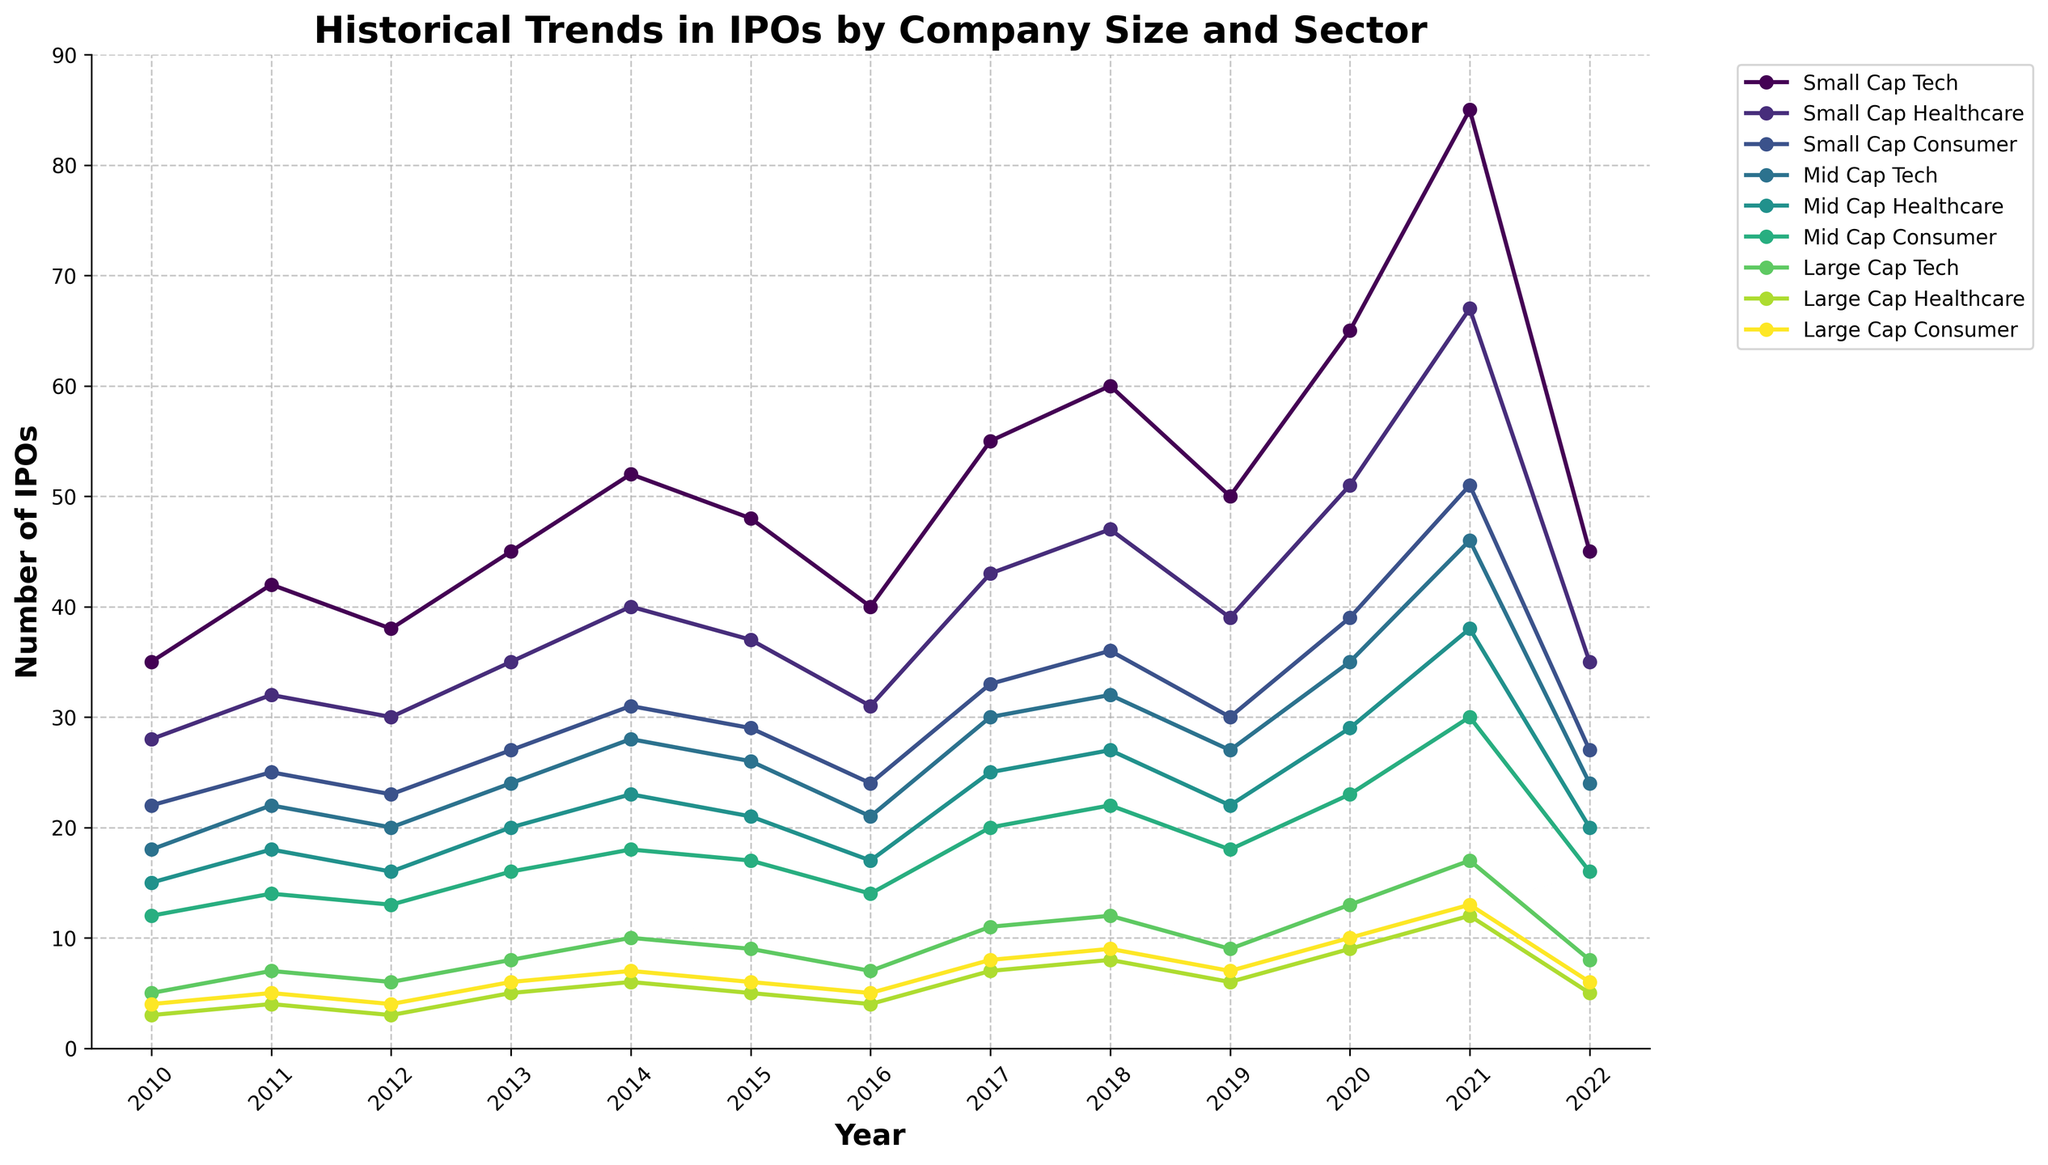What's the trend in the number of Small Cap Tech IPOs from 2010 to 2022? To determine this, observe the line representing Small Cap Tech from 2010 to 2022. The line starts at 35 in 2010, increases to 85 in 2021, and drops to 45 in 2022. There is an upward trend with a peak in 2021 followed by a drop in 2022.
Answer: Upward trend with a peak in 2021, then a drop Which sector had the highest number of IPOs in 2021? Check the highest point in each line for the year 2021. Small Cap Tech reaches 85, which is higher than any other sector for that year.
Answer: Small Cap Tech By how much did the number of Mid Cap Healthcare IPOs increase from 2010 to 2021? Look at the Mid Cap Healthcare line for the years 2010 and 2021. In 2010, it is at 15, and in 2021, it reaches 38. The increase is calculated as 38 - 15.
Answer: 23 What was the number of Large Cap Consumer IPOs in 2020 compared to 2022? Observe the Large Cap Consumer line for the years 2020 and 2022. In 2020, the value is 10, and in 2022 the value is 6.
Answer: Decreased by 4 Which sector had the lowest number of IPOs in 2016? Find the lowest point among all categories in 2016. Large Cap Healthcare shows the smallest value at 4.
Answer: Large Cap Healthcare What’s the sum of Small Cap Consumer IPOs in 2017 and Large Cap Tech IPOs in 2017? Locate the values for Small Cap Consumer and Large Cap Tech in 2017, which are 33 and 11 respectively. Sum them: 33 + 11.
Answer: 44 What is the average number of IPOs for Mid Cap Tech over the period 2010-2022? Sum the Mid Cap Tech values for each year and divide by the number of years (13). The values are: [18, 22, 20, 24, 28, 26, 21, 30, 32, 27, 35, 46, 24]. Sum: (18 + 22 + 20 + 24 + 28 + 26 + 21 + 30 + 32 + 27 + 35 + 46 + 24) = 353. Average: 353 / 13.
Answer: 27.15 How does the number of Small Cap Healthcare IPOs in 2018 compare to 2019? Locate the values for Small Cap Healthcare in 2018 and 2019, which are 47 and 39 respectively.
Answer: Less in 2019 Which categories show a decrease in IPOs from 2021 to 2022? Compare the 2021 and 2022 values for each category. Categories with a decrease will show a lower number in 2022. Decreases are observed in Small Cap Tech, Small Cap Healthcare, Small Cap Consumer, Mid Cap Tech, Mid Cap Healthcare, Mid Cap Consumer, Large Cap Tech, Large Cap Healthcare, Large Cap Consumer.
Answer: All categories 